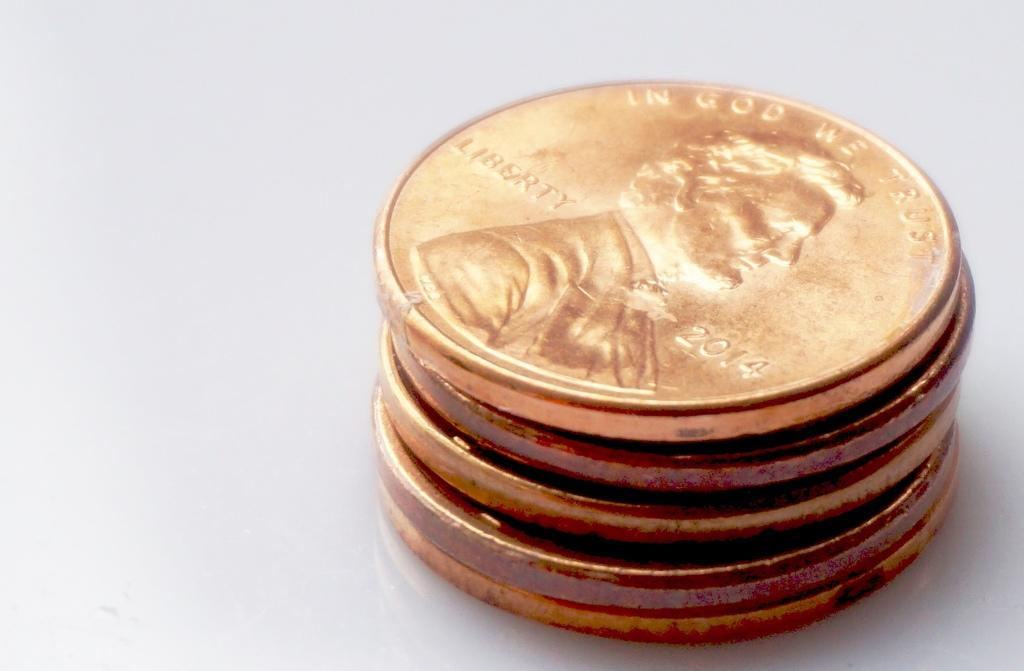What is the main subject of the image? The main subject of the image is a stack of coins. Can you describe the appearance of the coins? The coins are stacked on top of each other in the image. How many coins are visible in the stack? The number of coins in the stack cannot be determined from the image alone. What type of flower is growing in the middle of the coin stack? There is no flower present in the image; it only features a stack of coins. 